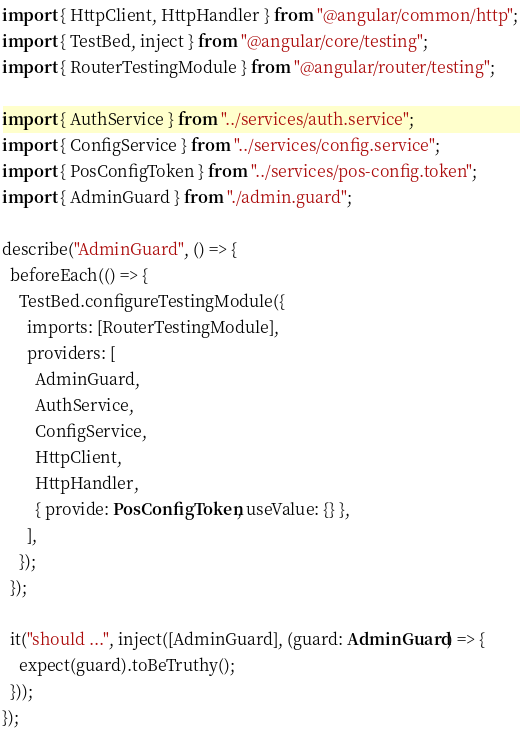<code> <loc_0><loc_0><loc_500><loc_500><_TypeScript_>import { HttpClient, HttpHandler } from "@angular/common/http";
import { TestBed, inject } from "@angular/core/testing";
import { RouterTestingModule } from "@angular/router/testing";

import { AuthService } from "../services/auth.service";
import { ConfigService } from "../services/config.service";
import { PosConfigToken } from "../services/pos-config.token";
import { AdminGuard } from "./admin.guard";

describe("AdminGuard", () => {
  beforeEach(() => {
    TestBed.configureTestingModule({
      imports: [RouterTestingModule],
      providers: [
        AdminGuard,
        AuthService,
        ConfigService,
        HttpClient,
        HttpHandler,
        { provide: PosConfigToken, useValue: {} },
      ],
    });
  });

  it("should ...", inject([AdminGuard], (guard: AdminGuard) => {
    expect(guard).toBeTruthy();
  }));
});
</code> 